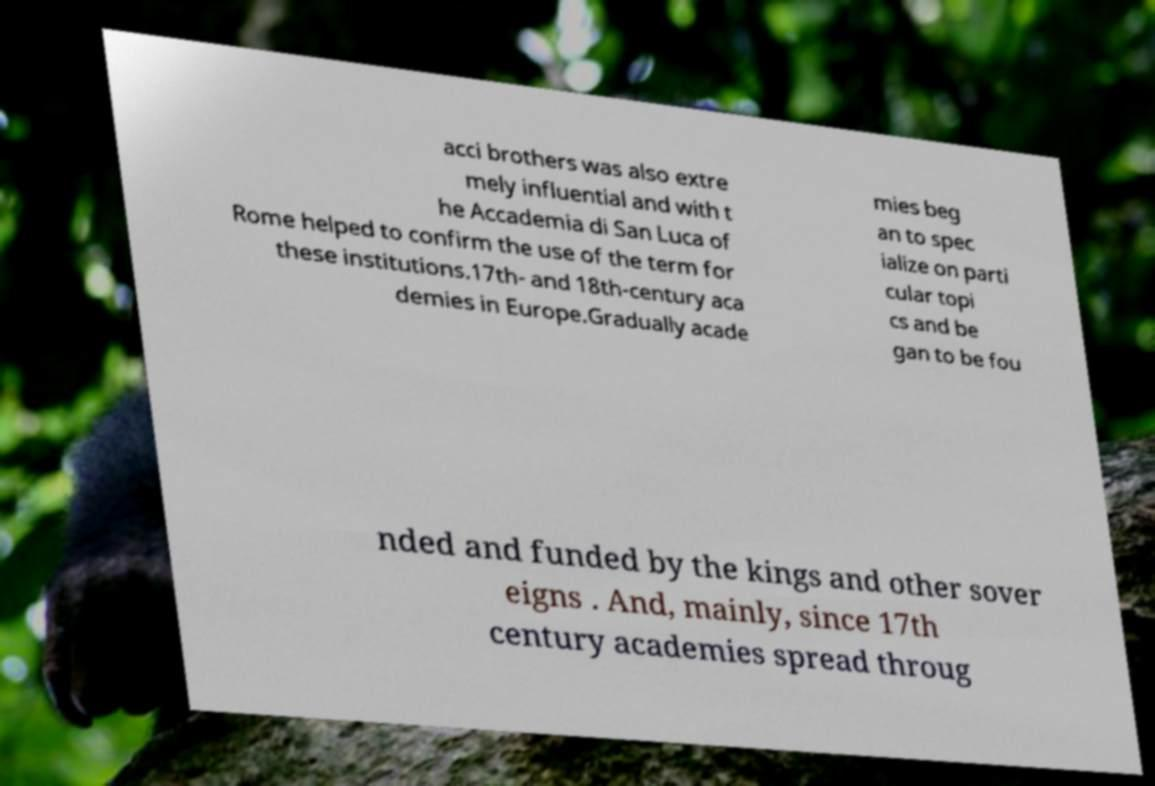What messages or text are displayed in this image? I need them in a readable, typed format. acci brothers was also extre mely influential and with t he Accademia di San Luca of Rome helped to confirm the use of the term for these institutions.17th- and 18th-century aca demies in Europe.Gradually acade mies beg an to spec ialize on parti cular topi cs and be gan to be fou nded and funded by the kings and other sover eigns . And, mainly, since 17th century academies spread throug 